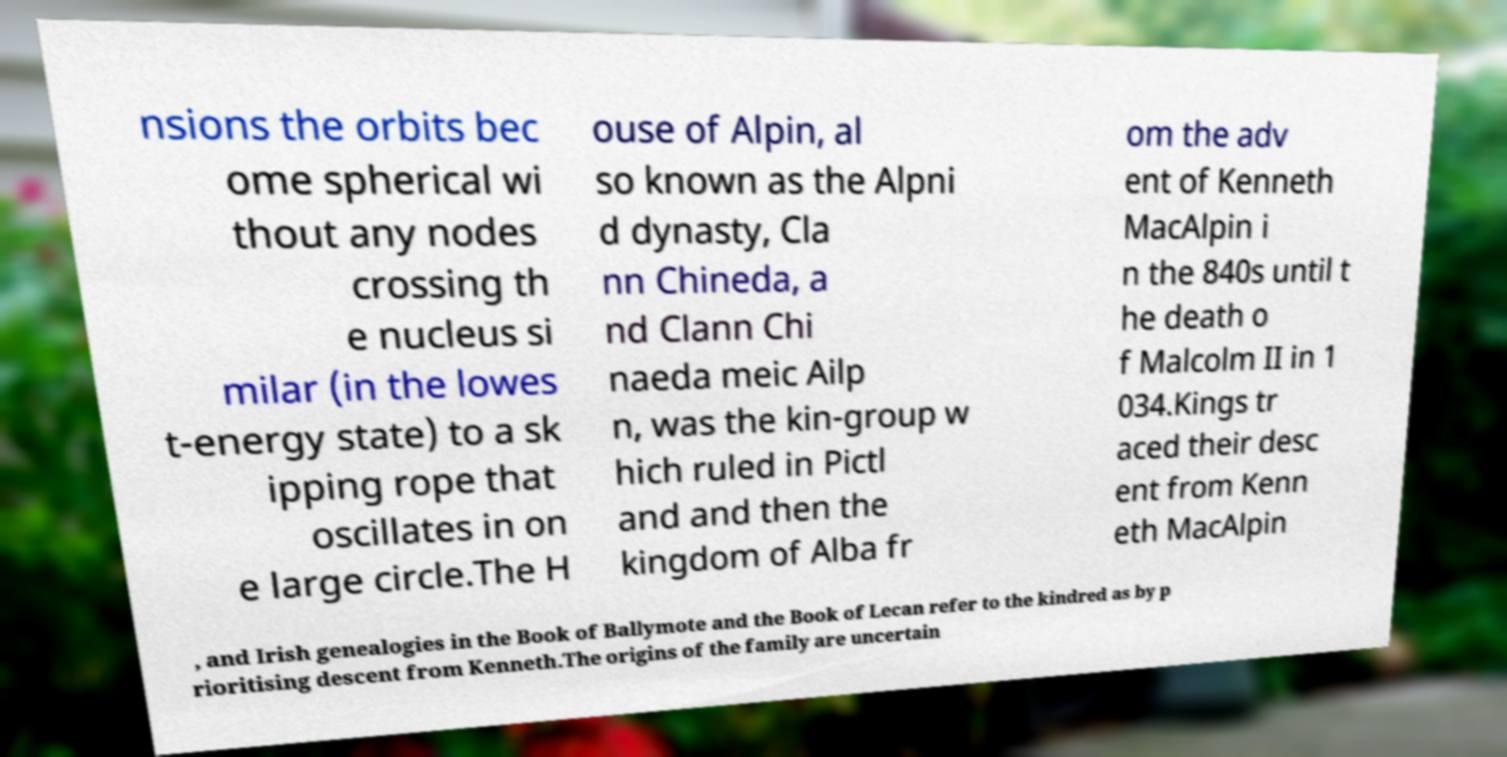Can you accurately transcribe the text from the provided image for me? nsions the orbits bec ome spherical wi thout any nodes crossing th e nucleus si milar (in the lowes t-energy state) to a sk ipping rope that oscillates in on e large circle.The H ouse of Alpin, al so known as the Alpni d dynasty, Cla nn Chineda, a nd Clann Chi naeda meic Ailp n, was the kin-group w hich ruled in Pictl and and then the kingdom of Alba fr om the adv ent of Kenneth MacAlpin i n the 840s until t he death o f Malcolm II in 1 034.Kings tr aced their desc ent from Kenn eth MacAlpin , and Irish genealogies in the Book of Ballymote and the Book of Lecan refer to the kindred as by p rioritising descent from Kenneth.The origins of the family are uncertain 